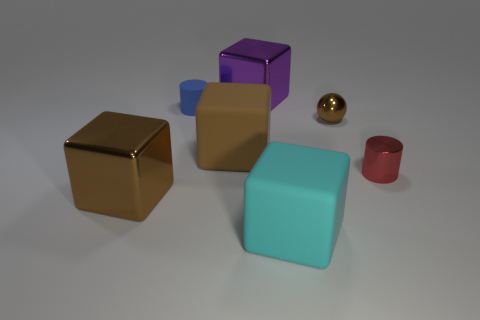Add 2 blue things. How many objects exist? 9 Subtract all large cyan rubber blocks. How many blocks are left? 3 Subtract 1 cubes. How many cubes are left? 3 Subtract all balls. How many objects are left? 6 Subtract all big blocks. Subtract all brown metallic objects. How many objects are left? 1 Add 4 small brown spheres. How many small brown spheres are left? 5 Add 7 large green rubber blocks. How many large green rubber blocks exist? 7 Subtract all blue cylinders. How many cylinders are left? 1 Subtract 0 green blocks. How many objects are left? 7 Subtract all green blocks. Subtract all yellow balls. How many blocks are left? 4 